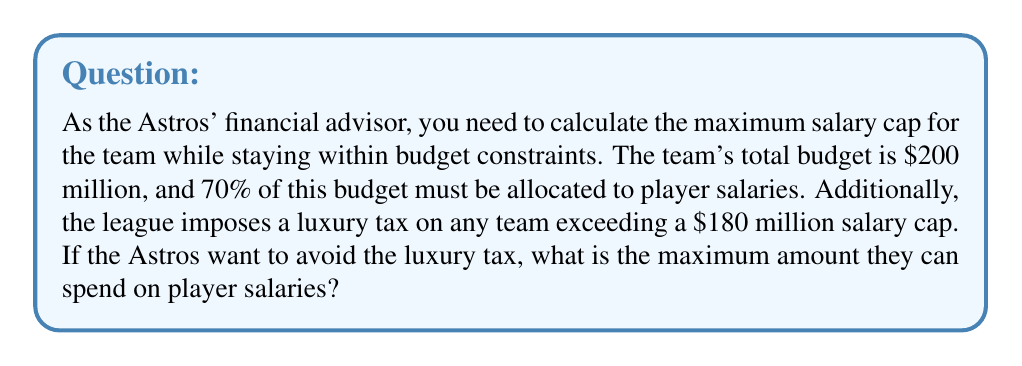Show me your answer to this math problem. Let's approach this step-by-step:

1. Calculate 70% of the total budget:
   $$ 0.70 \times \$200,000,000 = \$140,000,000 $$

2. This $140 million is the minimum amount that must be spent on player salaries.

3. Now, we need to compare this with the luxury tax threshold of $180 million:
   $$ \$180,000,000 > \$140,000,000 $$

4. Since the luxury tax threshold is higher than the minimum required spending on salaries, we can spend up to the luxury tax threshold without incurring penalties.

5. Therefore, the maximum amount that can be spent on player salaries while avoiding the luxury tax is $180 million.

6. We can verify that this is within the budget constraints:
   $$ \frac{\$180,000,000}{\$200,000,000} \times 100\% = 90\% $$

   This is greater than the required 70%, so it satisfies the budget allocation requirement.
Answer: $180 million 